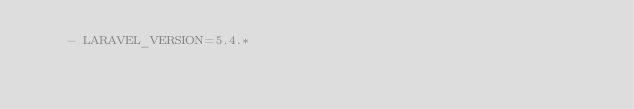Convert code to text. <code><loc_0><loc_0><loc_500><loc_500><_YAML_>    - LARAVEL_VERSION=5.4.*</code> 